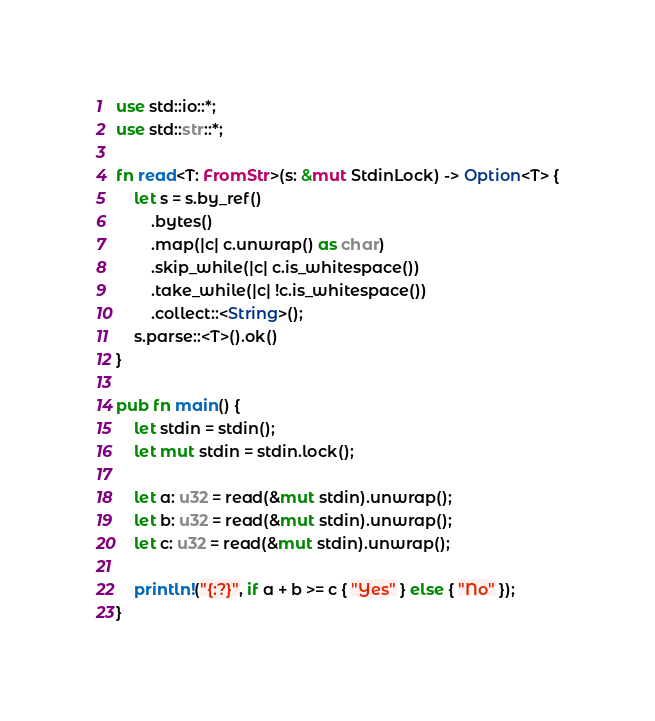<code> <loc_0><loc_0><loc_500><loc_500><_Rust_>use std::io::*;
use std::str::*;

fn read<T: FromStr>(s: &mut StdinLock) -> Option<T> {
    let s = s.by_ref()
        .bytes()
        .map(|c| c.unwrap() as char)
        .skip_while(|c| c.is_whitespace())
        .take_while(|c| !c.is_whitespace())
        .collect::<String>();
    s.parse::<T>().ok()
}

pub fn main() {
    let stdin = stdin();
    let mut stdin = stdin.lock();

    let a: u32 = read(&mut stdin).unwrap();
    let b: u32 = read(&mut stdin).unwrap();
    let c: u32 = read(&mut stdin).unwrap();

    println!("{:?}", if a + b >= c { "Yes" } else { "No" });
}
</code> 